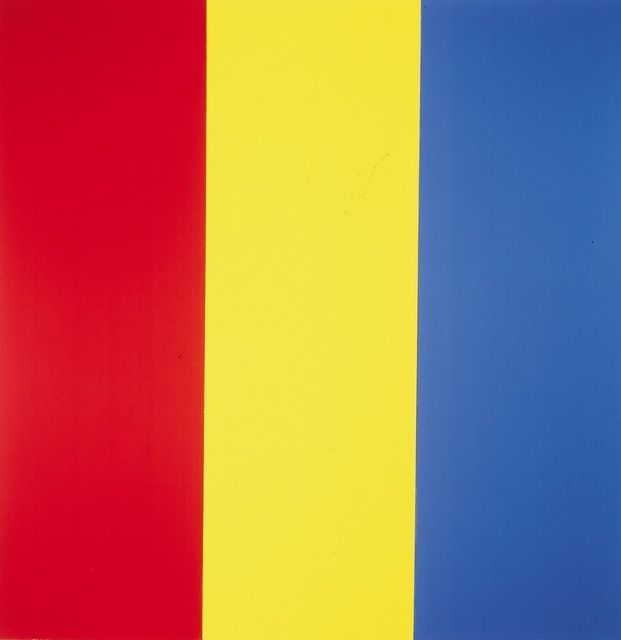What if these colors represented elements of nature, how would that change their interaction? In a fantastical world where colors ruled nature: Red symbolized fire, Yellow embodied sunlight, and Blue represented water. They conversed often at the edge of the enchanted forest where their elements intertwined.
Red (Fire): 'My flames cleanse and transform the earth, but I need you, Water, to temper my rage and prevent all-consuming destruction.'
Blue (Water): 'Indeed, Fire, without your heat, I would remain stagnant and cold. But I also provide the nourishment that the Sun’s light brings forth.'
Yellow (Sunlight): 'And my rays awaken life, invigorating plants and warming the hearts of creatures. Yet, I rely on your warmth, Fire, and your sustenance, Water, to complete the cycle of growth and renewal.'
Red: 'Together, our elements sustain this world. Fire, Water, and Sunlight in harmonious balance create the cradle of life.'
Yellow: 'Unified, we ensure the earth’s vitality and the flourishing of every living being.'
Blue: 'Our bond is the essence of nature’s equilibrium, each element guiding and nurturing the next.' 